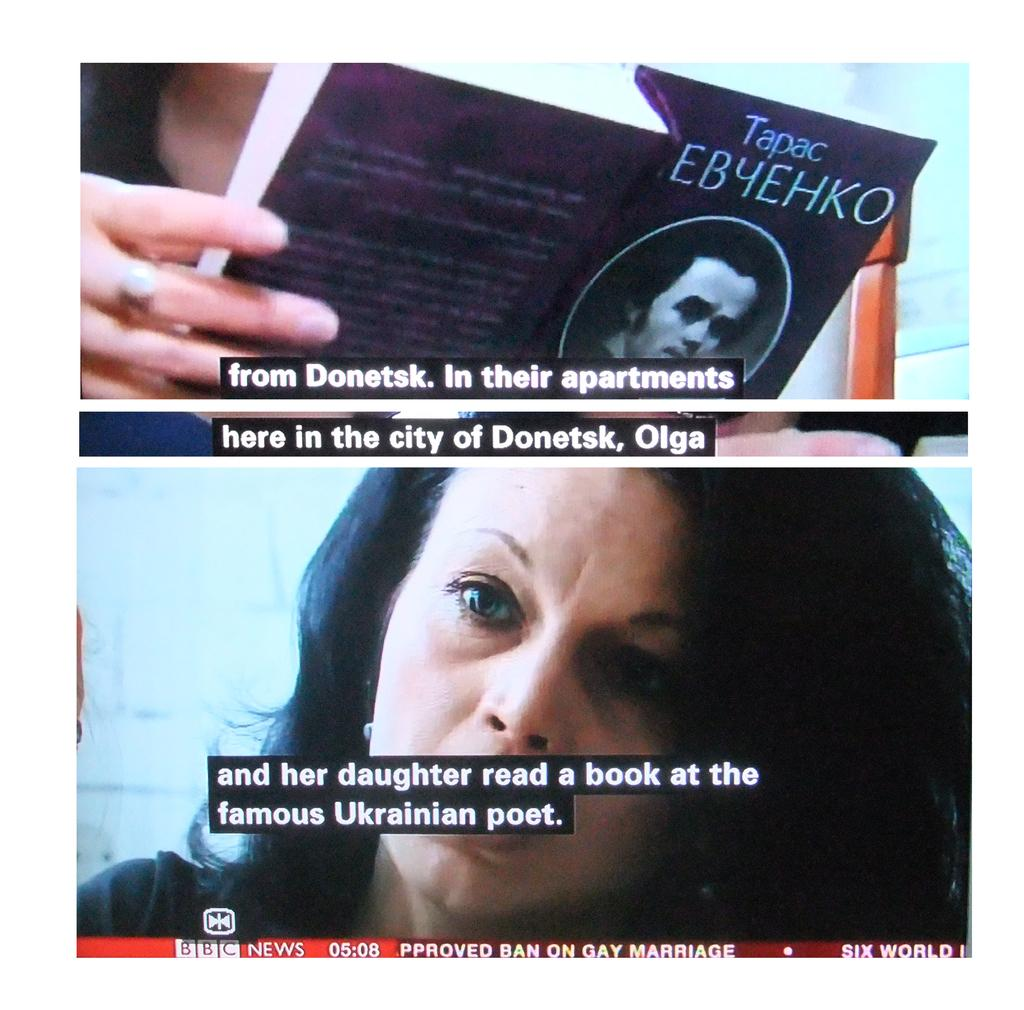What type of image is being described? The image is a collage. Can you identify any person or object in the image? Yes, there is a person holding a book in the image. Are there any words or phrases written on the image? Yes, there is text written on the image. What is the scrolling at the bottom of the image? The scrolling at the bottom of the image is likely a continuous stream of text or images. Can you see a brush being used to paint the river in the image? There is no brush or river present in the image. What type of stamp is visible on the person holding the book? There is no stamp visible on the person holding the book in the image. 